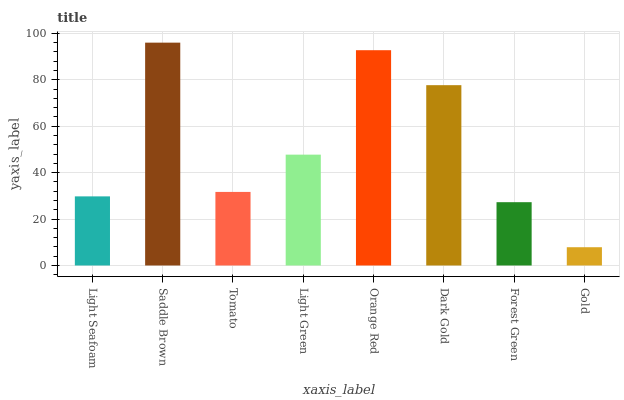Is Gold the minimum?
Answer yes or no. Yes. Is Saddle Brown the maximum?
Answer yes or no. Yes. Is Tomato the minimum?
Answer yes or no. No. Is Tomato the maximum?
Answer yes or no. No. Is Saddle Brown greater than Tomato?
Answer yes or no. Yes. Is Tomato less than Saddle Brown?
Answer yes or no. Yes. Is Tomato greater than Saddle Brown?
Answer yes or no. No. Is Saddle Brown less than Tomato?
Answer yes or no. No. Is Light Green the high median?
Answer yes or no. Yes. Is Tomato the low median?
Answer yes or no. Yes. Is Saddle Brown the high median?
Answer yes or no. No. Is Dark Gold the low median?
Answer yes or no. No. 